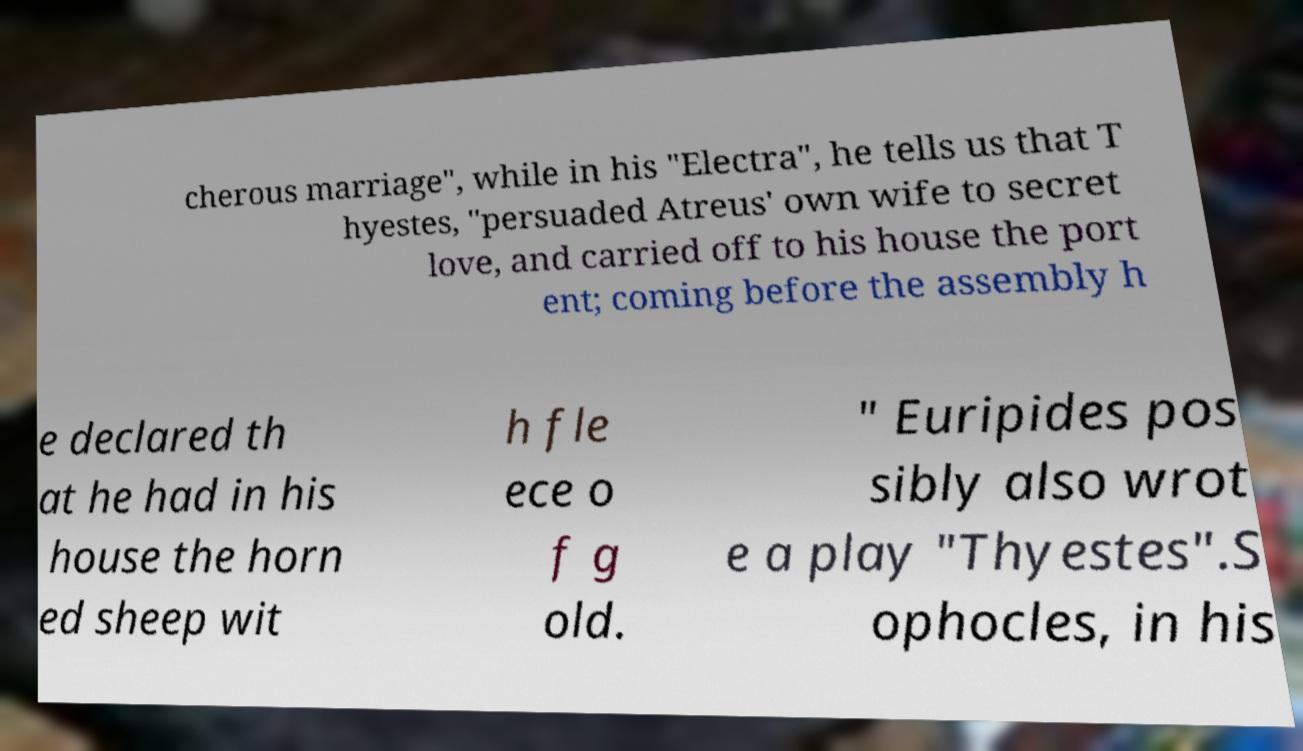There's text embedded in this image that I need extracted. Can you transcribe it verbatim? cherous marriage", while in his "Electra", he tells us that T hyestes, "persuaded Atreus' own wife to secret love, and carried off to his house the port ent; coming before the assembly h e declared th at he had in his house the horn ed sheep wit h fle ece o f g old. " Euripides pos sibly also wrot e a play "Thyestes".S ophocles, in his 